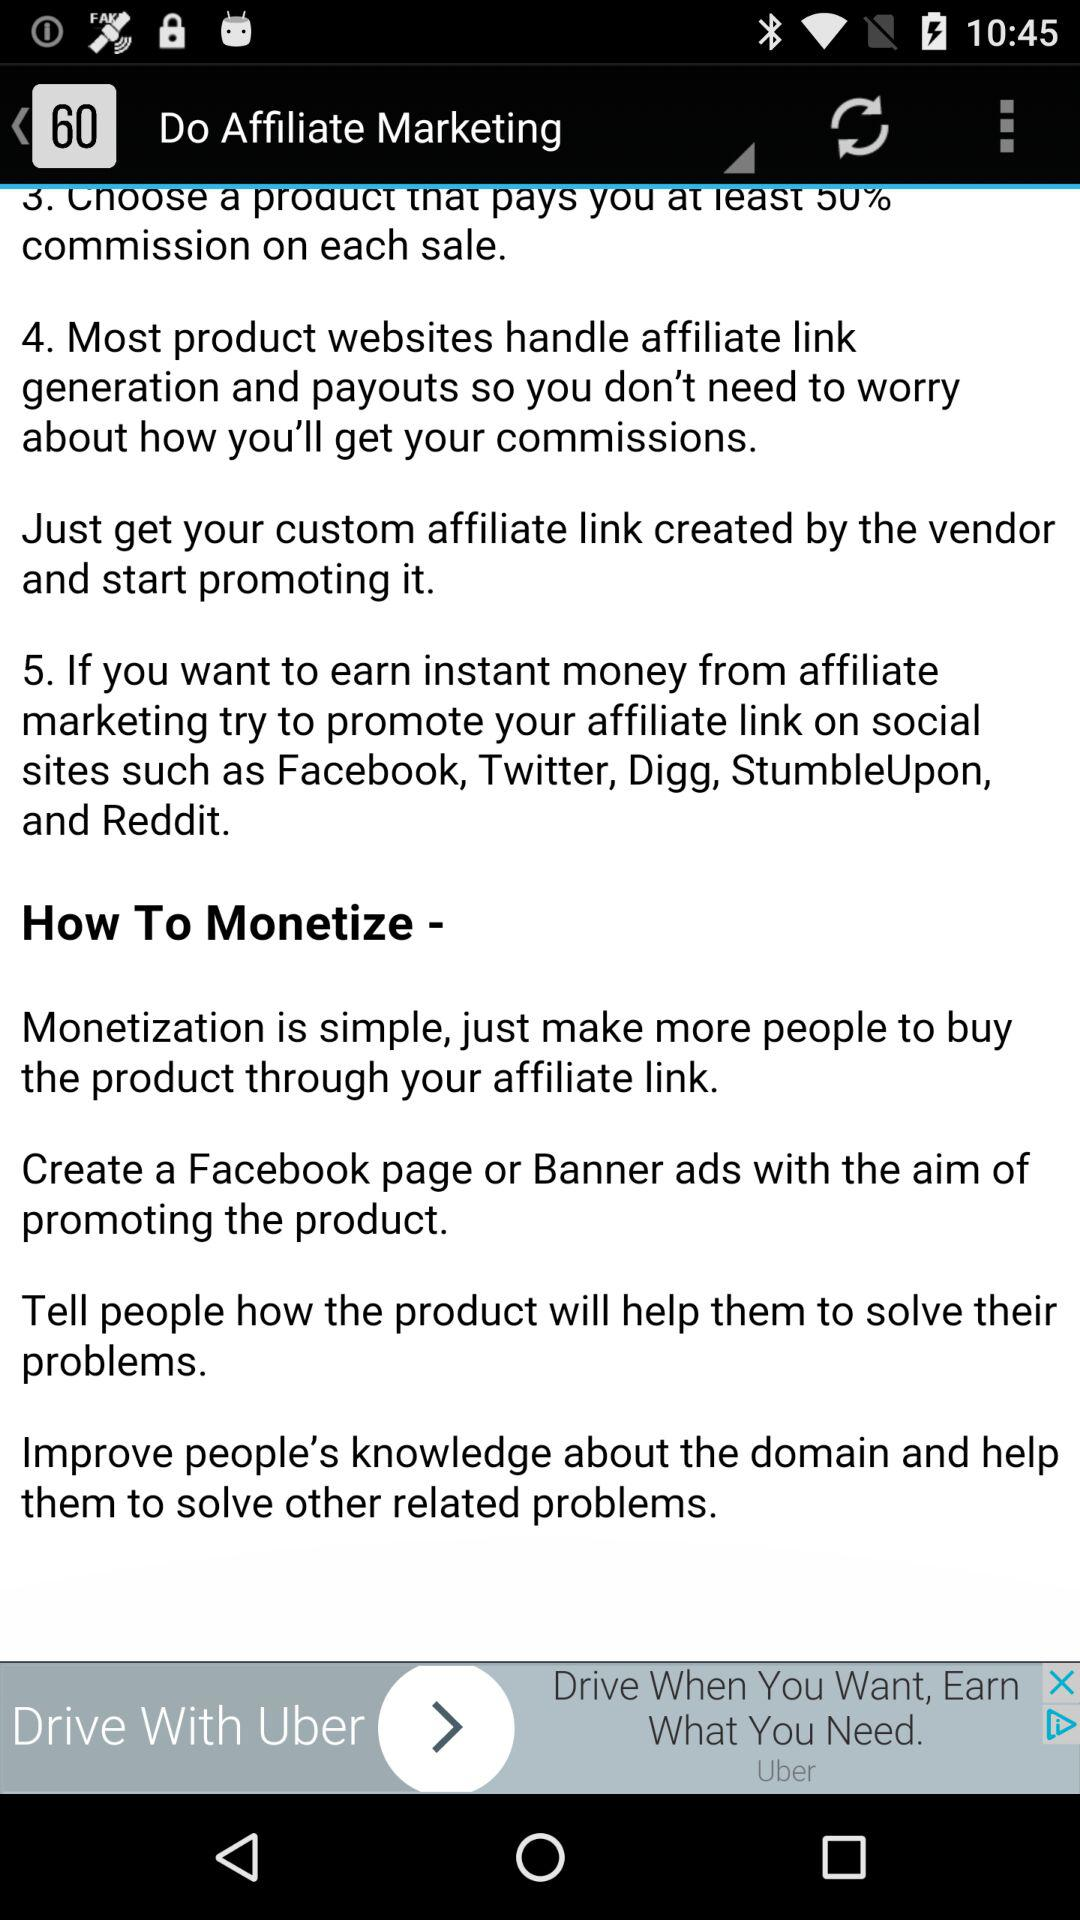How many steps are there in the 'How to Affiliate Market' section?
Answer the question using a single word or phrase. 5 